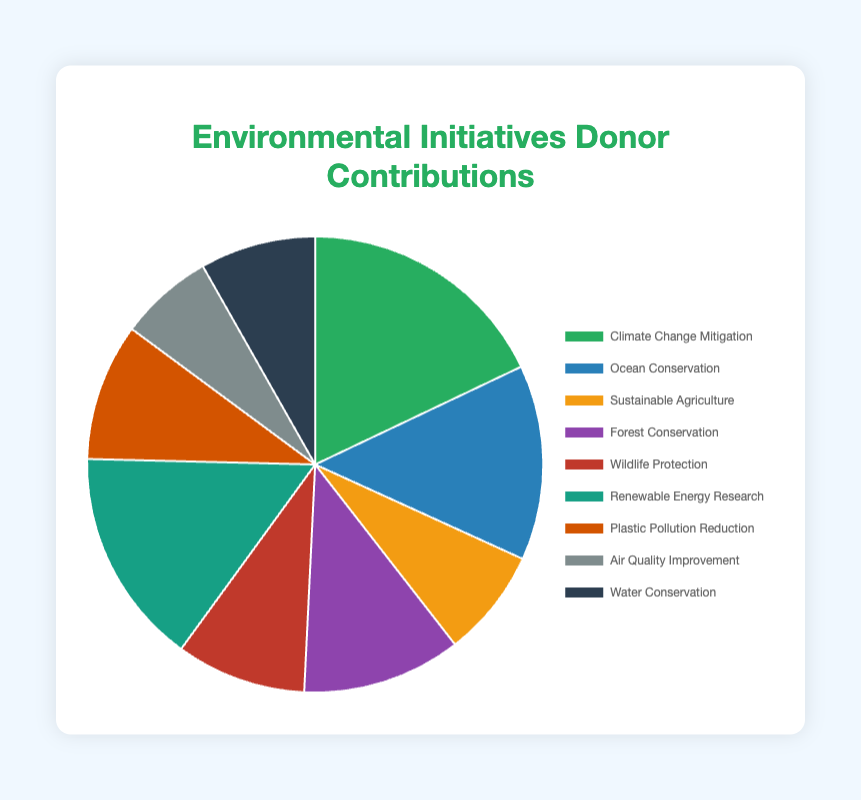What's the total donation amount for Climate Change Mitigation and Ocean Conservation? First, identify the donation amounts for "Climate Change Mitigation" ($350,000) and "Ocean Conservation" ($270,000). Then, sum these amounts: $350,000 + $270,000 = $620,000.
Answer: $620,000 Which initiative received the highest donation? Check the donation amounts for all initiatives and identify the highest one. "Climate Change Mitigation" received $350,000, which is the highest among the listed initiatives.
Answer: Climate Change Mitigation Which initiative received more funding, Renewable Energy Research or Forest Conservation? Compare the donation amounts: Renewable Energy Research received $300,000, and Forest Conservation received $220,000. $300,000 is greater than $220,000.
Answer: Renewable Energy Research What percentage of the total donations was contributed to Plastic Pollution Reduction? Calculate the total donations by summing all contributions: $350,000 + $270,000 + $150,000 + $220,000 + $180,000 + $300,000 + $190,000 + $130,000 + $160,000 = $1,950,000. Then, divide the donation for Plastic Pollution Reduction by the total and multiply by 100: ($190,000 / $1,950,000) * 100 ≈ 9.74%.
Answer: 9.74% What's the difference in donation amounts between Wildlife Protection and Water Conservation? Identify the donation amounts for Wildlife Protection ($180,000) and Water Conservation ($160,000). Subtract the smaller amount from the larger one: $180,000 - $160,000 = $20,000.
Answer: $20,000 Which initiative is represented by the green segment in the pie chart? Visually identify the color associated with "Climate Change Mitigation," which is green based on the description of segment colors in the code.
Answer: Climate Change Mitigation 